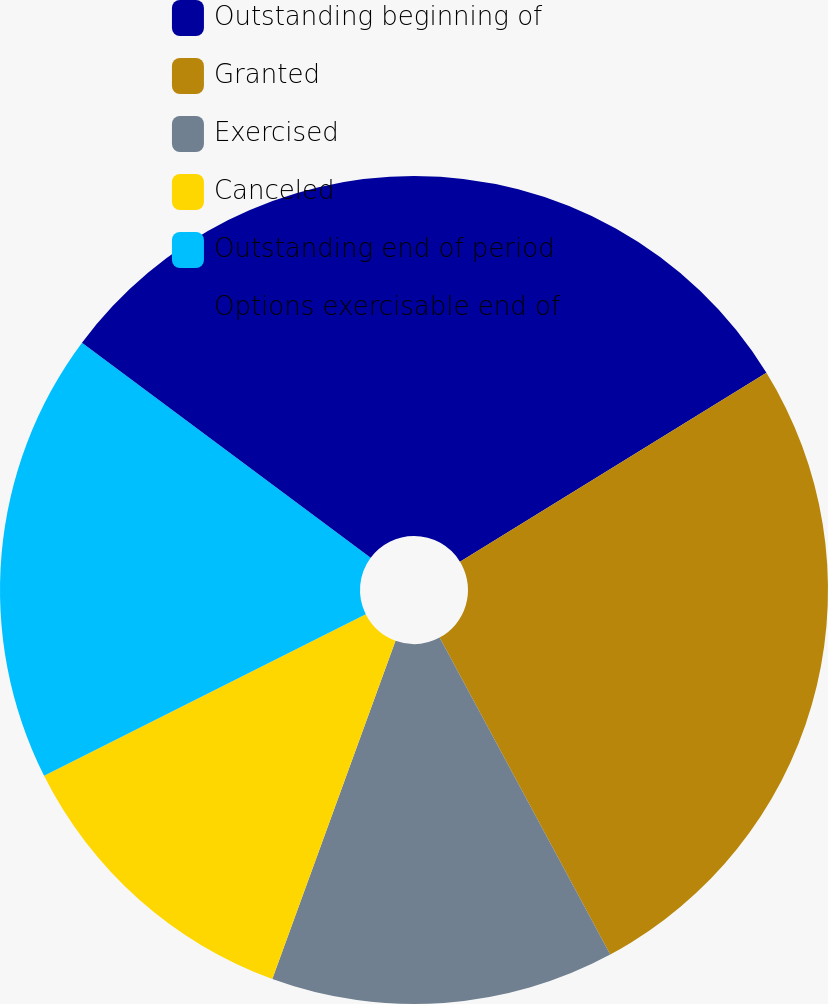<chart> <loc_0><loc_0><loc_500><loc_500><pie_chart><fcel>Outstanding beginning of<fcel>Granted<fcel>Exercised<fcel>Canceled<fcel>Outstanding end of period<fcel>Options exercisable end of<nl><fcel>16.21%<fcel>25.93%<fcel>13.42%<fcel>12.03%<fcel>17.6%<fcel>14.81%<nl></chart> 